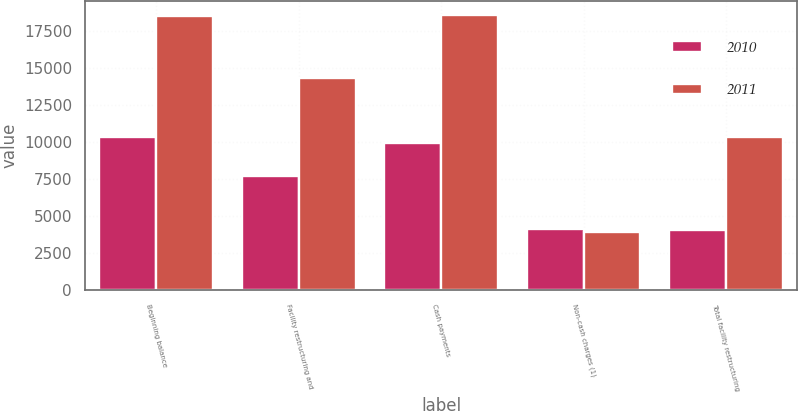Convert chart. <chart><loc_0><loc_0><loc_500><loc_500><stacked_bar_chart><ecel><fcel>Beginning balance<fcel>Facility restructuring and<fcel>Cash payments<fcel>Non-cash charges (1)<fcel>Total facility restructuring<nl><fcel>2010<fcel>10371<fcel>7706<fcel>9920<fcel>4096<fcel>4061<nl><fcel>2011<fcel>18529<fcel>14346<fcel>18591<fcel>3913<fcel>10371<nl></chart> 